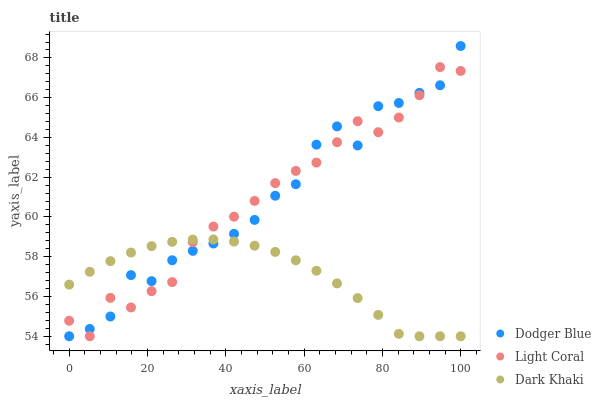Does Dark Khaki have the minimum area under the curve?
Answer yes or no. Yes. Does Dodger Blue have the maximum area under the curve?
Answer yes or no. Yes. Does Dodger Blue have the minimum area under the curve?
Answer yes or no. No. Does Dark Khaki have the maximum area under the curve?
Answer yes or no. No. Is Dark Khaki the smoothest?
Answer yes or no. Yes. Is Dodger Blue the roughest?
Answer yes or no. Yes. Is Dodger Blue the smoothest?
Answer yes or no. No. Is Dark Khaki the roughest?
Answer yes or no. No. Does Light Coral have the lowest value?
Answer yes or no. Yes. Does Dodger Blue have the highest value?
Answer yes or no. Yes. Does Dark Khaki have the highest value?
Answer yes or no. No. Does Dark Khaki intersect Light Coral?
Answer yes or no. Yes. Is Dark Khaki less than Light Coral?
Answer yes or no. No. Is Dark Khaki greater than Light Coral?
Answer yes or no. No. 